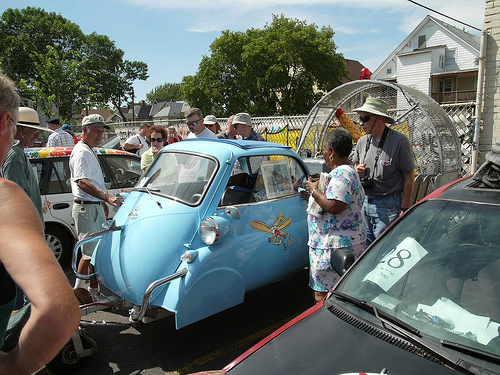<image>
Is the man to the left of the blue car? No. The man is not to the left of the blue car. From this viewpoint, they have a different horizontal relationship. 